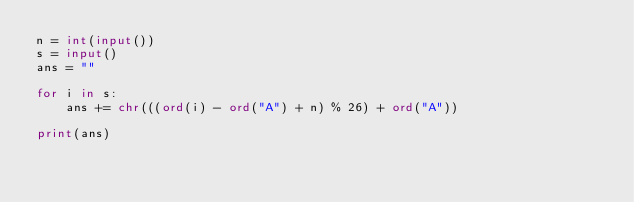<code> <loc_0><loc_0><loc_500><loc_500><_Python_>n = int(input())
s = input()
ans = ""

for i in s:
	ans += chr(((ord(i) - ord("A") + n) % 26) + ord("A"))

print(ans)</code> 